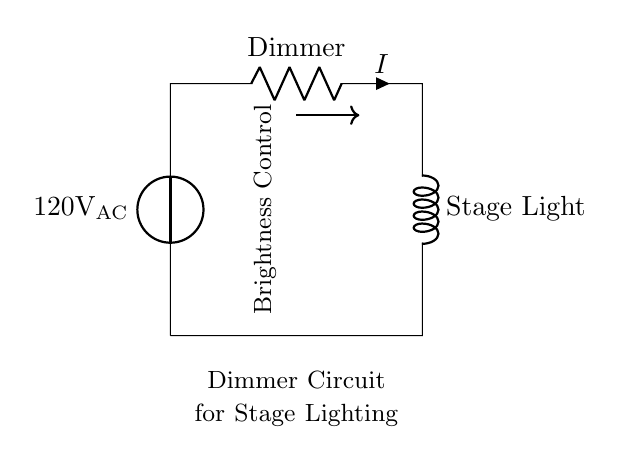What type of circuit is this? The circuit is a dimmer circuit, which is used for adjusting the brightness of stage lighting. It consists of a voltage source, a resistor, and an inductor, typical in AC applications.
Answer: dimmer circuit What is the voltage source in this circuit? The voltage source is labeled as 120 volts AC, indicating the potential difference supplied to the circuit.
Answer: 120 volts AC What component is labeled as 'Dimmer'? The component labeled as 'Dimmer' in the circuit is a resistor, which is used to control the current and adjust the light brightness.
Answer: resistor What is the function of the inductor in this circuit? The inductor, labeled 'Stage Light', is used to provide inductance in the circuit, which is essential for controlling the flow of current and managing the load of the lighting.
Answer: provide inductance How does changing the resistance affect brightness? Altering the resistance will change the current flowing through the inductor, which in turn adjusts the brightness of the stage lighting; less resistance results in brighter light, more resistance dims it.
Answer: it adjusts brightness What is the current direction indicated by the arrow? The current direction in the circuit is indicated by the arrow pointing from the dimmer to the inductor, showing the flow of electric charge in that path.
Answer: from dimmer to inductor 